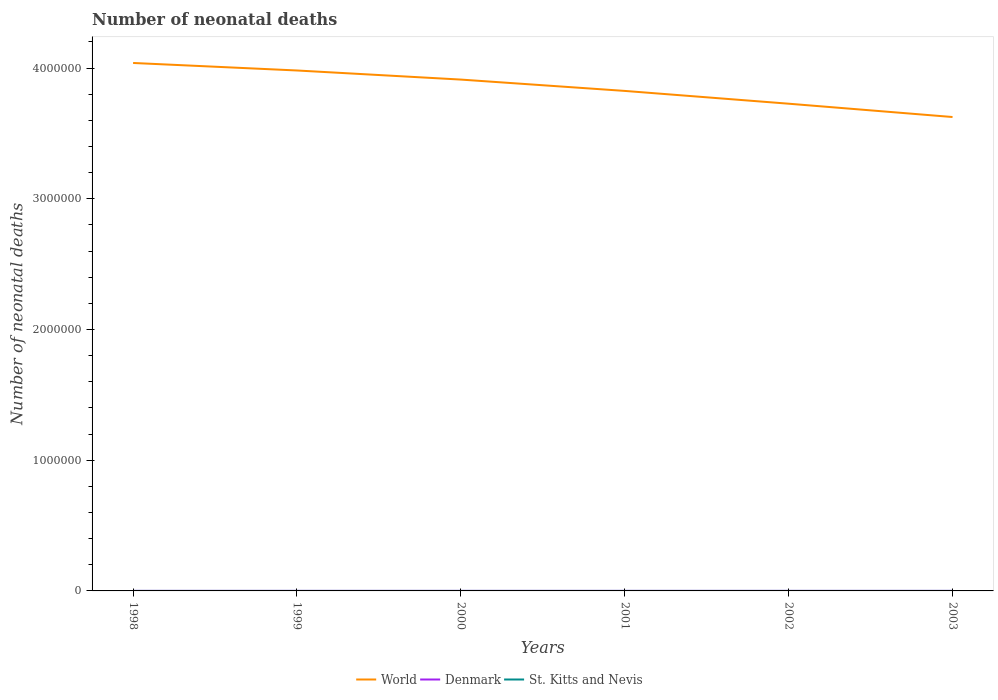Does the line corresponding to World intersect with the line corresponding to Denmark?
Your response must be concise. No. Across all years, what is the maximum number of neonatal deaths in in Denmark?
Your response must be concise. 203. In which year was the number of neonatal deaths in in Denmark maximum?
Keep it short and to the point. 2003. What is the total number of neonatal deaths in in Denmark in the graph?
Your answer should be compact. 36. What is the difference between the highest and the second highest number of neonatal deaths in in St. Kitts and Nevis?
Your answer should be compact. 3. What is the difference between the highest and the lowest number of neonatal deaths in in World?
Offer a terse response. 3. How many years are there in the graph?
Provide a succinct answer. 6. What is the difference between two consecutive major ticks on the Y-axis?
Give a very brief answer. 1.00e+06. Are the values on the major ticks of Y-axis written in scientific E-notation?
Keep it short and to the point. No. Does the graph contain any zero values?
Make the answer very short. No. Does the graph contain grids?
Make the answer very short. No. Where does the legend appear in the graph?
Provide a succinct answer. Bottom center. How are the legend labels stacked?
Offer a very short reply. Horizontal. What is the title of the graph?
Offer a terse response. Number of neonatal deaths. What is the label or title of the X-axis?
Your answer should be compact. Years. What is the label or title of the Y-axis?
Make the answer very short. Number of neonatal deaths. What is the Number of neonatal deaths in World in 1998?
Keep it short and to the point. 4.04e+06. What is the Number of neonatal deaths of Denmark in 1998?
Offer a terse response. 243. What is the Number of neonatal deaths of World in 1999?
Offer a terse response. 3.98e+06. What is the Number of neonatal deaths in Denmark in 1999?
Keep it short and to the point. 231. What is the Number of neonatal deaths in St. Kitts and Nevis in 1999?
Keep it short and to the point. 12. What is the Number of neonatal deaths of World in 2000?
Ensure brevity in your answer.  3.91e+06. What is the Number of neonatal deaths in Denmark in 2000?
Give a very brief answer. 221. What is the Number of neonatal deaths in World in 2001?
Provide a succinct answer. 3.83e+06. What is the Number of neonatal deaths in Denmark in 2001?
Give a very brief answer. 213. What is the Number of neonatal deaths of World in 2002?
Make the answer very short. 3.73e+06. What is the Number of neonatal deaths in Denmark in 2002?
Make the answer very short. 207. What is the Number of neonatal deaths in World in 2003?
Give a very brief answer. 3.63e+06. What is the Number of neonatal deaths in Denmark in 2003?
Offer a terse response. 203. Across all years, what is the maximum Number of neonatal deaths in World?
Make the answer very short. 4.04e+06. Across all years, what is the maximum Number of neonatal deaths of Denmark?
Keep it short and to the point. 243. Across all years, what is the maximum Number of neonatal deaths of St. Kitts and Nevis?
Offer a terse response. 13. Across all years, what is the minimum Number of neonatal deaths in World?
Keep it short and to the point. 3.63e+06. Across all years, what is the minimum Number of neonatal deaths of Denmark?
Your response must be concise. 203. Across all years, what is the minimum Number of neonatal deaths in St. Kitts and Nevis?
Ensure brevity in your answer.  10. What is the total Number of neonatal deaths in World in the graph?
Make the answer very short. 2.31e+07. What is the total Number of neonatal deaths in Denmark in the graph?
Provide a succinct answer. 1318. What is the difference between the Number of neonatal deaths in World in 1998 and that in 1999?
Your answer should be very brief. 5.75e+04. What is the difference between the Number of neonatal deaths of St. Kitts and Nevis in 1998 and that in 1999?
Keep it short and to the point. 1. What is the difference between the Number of neonatal deaths of World in 1998 and that in 2000?
Your response must be concise. 1.27e+05. What is the difference between the Number of neonatal deaths of Denmark in 1998 and that in 2000?
Give a very brief answer. 22. What is the difference between the Number of neonatal deaths in St. Kitts and Nevis in 1998 and that in 2000?
Your response must be concise. 1. What is the difference between the Number of neonatal deaths in World in 1998 and that in 2001?
Provide a short and direct response. 2.14e+05. What is the difference between the Number of neonatal deaths in World in 1998 and that in 2002?
Your answer should be very brief. 3.12e+05. What is the difference between the Number of neonatal deaths of World in 1998 and that in 2003?
Your answer should be compact. 4.14e+05. What is the difference between the Number of neonatal deaths of Denmark in 1998 and that in 2003?
Your answer should be compact. 40. What is the difference between the Number of neonatal deaths of World in 1999 and that in 2000?
Your answer should be very brief. 6.96e+04. What is the difference between the Number of neonatal deaths in St. Kitts and Nevis in 1999 and that in 2000?
Your answer should be very brief. 0. What is the difference between the Number of neonatal deaths in World in 1999 and that in 2001?
Make the answer very short. 1.56e+05. What is the difference between the Number of neonatal deaths of Denmark in 1999 and that in 2001?
Provide a succinct answer. 18. What is the difference between the Number of neonatal deaths of St. Kitts and Nevis in 1999 and that in 2001?
Provide a short and direct response. 1. What is the difference between the Number of neonatal deaths of World in 1999 and that in 2002?
Your answer should be compact. 2.54e+05. What is the difference between the Number of neonatal deaths of Denmark in 1999 and that in 2002?
Your answer should be very brief. 24. What is the difference between the Number of neonatal deaths in World in 1999 and that in 2003?
Keep it short and to the point. 3.56e+05. What is the difference between the Number of neonatal deaths of Denmark in 1999 and that in 2003?
Give a very brief answer. 28. What is the difference between the Number of neonatal deaths of World in 2000 and that in 2001?
Keep it short and to the point. 8.67e+04. What is the difference between the Number of neonatal deaths of St. Kitts and Nevis in 2000 and that in 2001?
Keep it short and to the point. 1. What is the difference between the Number of neonatal deaths in World in 2000 and that in 2002?
Keep it short and to the point. 1.85e+05. What is the difference between the Number of neonatal deaths of St. Kitts and Nevis in 2000 and that in 2002?
Provide a short and direct response. 2. What is the difference between the Number of neonatal deaths of World in 2000 and that in 2003?
Give a very brief answer. 2.86e+05. What is the difference between the Number of neonatal deaths in St. Kitts and Nevis in 2000 and that in 2003?
Your answer should be compact. 2. What is the difference between the Number of neonatal deaths of World in 2001 and that in 2002?
Your answer should be compact. 9.79e+04. What is the difference between the Number of neonatal deaths in St. Kitts and Nevis in 2001 and that in 2002?
Ensure brevity in your answer.  1. What is the difference between the Number of neonatal deaths in World in 2001 and that in 2003?
Your response must be concise. 2.00e+05. What is the difference between the Number of neonatal deaths of St. Kitts and Nevis in 2001 and that in 2003?
Offer a terse response. 1. What is the difference between the Number of neonatal deaths of World in 2002 and that in 2003?
Provide a succinct answer. 1.02e+05. What is the difference between the Number of neonatal deaths of Denmark in 2002 and that in 2003?
Provide a succinct answer. 4. What is the difference between the Number of neonatal deaths in World in 1998 and the Number of neonatal deaths in Denmark in 1999?
Make the answer very short. 4.04e+06. What is the difference between the Number of neonatal deaths of World in 1998 and the Number of neonatal deaths of St. Kitts and Nevis in 1999?
Keep it short and to the point. 4.04e+06. What is the difference between the Number of neonatal deaths in Denmark in 1998 and the Number of neonatal deaths in St. Kitts and Nevis in 1999?
Offer a very short reply. 231. What is the difference between the Number of neonatal deaths in World in 1998 and the Number of neonatal deaths in Denmark in 2000?
Provide a short and direct response. 4.04e+06. What is the difference between the Number of neonatal deaths of World in 1998 and the Number of neonatal deaths of St. Kitts and Nevis in 2000?
Offer a very short reply. 4.04e+06. What is the difference between the Number of neonatal deaths of Denmark in 1998 and the Number of neonatal deaths of St. Kitts and Nevis in 2000?
Offer a very short reply. 231. What is the difference between the Number of neonatal deaths of World in 1998 and the Number of neonatal deaths of Denmark in 2001?
Your answer should be compact. 4.04e+06. What is the difference between the Number of neonatal deaths in World in 1998 and the Number of neonatal deaths in St. Kitts and Nevis in 2001?
Your answer should be very brief. 4.04e+06. What is the difference between the Number of neonatal deaths of Denmark in 1998 and the Number of neonatal deaths of St. Kitts and Nevis in 2001?
Your response must be concise. 232. What is the difference between the Number of neonatal deaths in World in 1998 and the Number of neonatal deaths in Denmark in 2002?
Your answer should be very brief. 4.04e+06. What is the difference between the Number of neonatal deaths in World in 1998 and the Number of neonatal deaths in St. Kitts and Nevis in 2002?
Offer a terse response. 4.04e+06. What is the difference between the Number of neonatal deaths in Denmark in 1998 and the Number of neonatal deaths in St. Kitts and Nevis in 2002?
Offer a terse response. 233. What is the difference between the Number of neonatal deaths in World in 1998 and the Number of neonatal deaths in Denmark in 2003?
Provide a short and direct response. 4.04e+06. What is the difference between the Number of neonatal deaths in World in 1998 and the Number of neonatal deaths in St. Kitts and Nevis in 2003?
Your answer should be very brief. 4.04e+06. What is the difference between the Number of neonatal deaths in Denmark in 1998 and the Number of neonatal deaths in St. Kitts and Nevis in 2003?
Your answer should be compact. 233. What is the difference between the Number of neonatal deaths of World in 1999 and the Number of neonatal deaths of Denmark in 2000?
Provide a succinct answer. 3.98e+06. What is the difference between the Number of neonatal deaths in World in 1999 and the Number of neonatal deaths in St. Kitts and Nevis in 2000?
Offer a very short reply. 3.98e+06. What is the difference between the Number of neonatal deaths in Denmark in 1999 and the Number of neonatal deaths in St. Kitts and Nevis in 2000?
Provide a succinct answer. 219. What is the difference between the Number of neonatal deaths in World in 1999 and the Number of neonatal deaths in Denmark in 2001?
Your answer should be very brief. 3.98e+06. What is the difference between the Number of neonatal deaths of World in 1999 and the Number of neonatal deaths of St. Kitts and Nevis in 2001?
Offer a terse response. 3.98e+06. What is the difference between the Number of neonatal deaths in Denmark in 1999 and the Number of neonatal deaths in St. Kitts and Nevis in 2001?
Provide a succinct answer. 220. What is the difference between the Number of neonatal deaths in World in 1999 and the Number of neonatal deaths in Denmark in 2002?
Give a very brief answer. 3.98e+06. What is the difference between the Number of neonatal deaths of World in 1999 and the Number of neonatal deaths of St. Kitts and Nevis in 2002?
Ensure brevity in your answer.  3.98e+06. What is the difference between the Number of neonatal deaths in Denmark in 1999 and the Number of neonatal deaths in St. Kitts and Nevis in 2002?
Keep it short and to the point. 221. What is the difference between the Number of neonatal deaths of World in 1999 and the Number of neonatal deaths of Denmark in 2003?
Ensure brevity in your answer.  3.98e+06. What is the difference between the Number of neonatal deaths of World in 1999 and the Number of neonatal deaths of St. Kitts and Nevis in 2003?
Make the answer very short. 3.98e+06. What is the difference between the Number of neonatal deaths in Denmark in 1999 and the Number of neonatal deaths in St. Kitts and Nevis in 2003?
Make the answer very short. 221. What is the difference between the Number of neonatal deaths of World in 2000 and the Number of neonatal deaths of Denmark in 2001?
Offer a terse response. 3.91e+06. What is the difference between the Number of neonatal deaths in World in 2000 and the Number of neonatal deaths in St. Kitts and Nevis in 2001?
Ensure brevity in your answer.  3.91e+06. What is the difference between the Number of neonatal deaths in Denmark in 2000 and the Number of neonatal deaths in St. Kitts and Nevis in 2001?
Your response must be concise. 210. What is the difference between the Number of neonatal deaths of World in 2000 and the Number of neonatal deaths of Denmark in 2002?
Give a very brief answer. 3.91e+06. What is the difference between the Number of neonatal deaths of World in 2000 and the Number of neonatal deaths of St. Kitts and Nevis in 2002?
Provide a short and direct response. 3.91e+06. What is the difference between the Number of neonatal deaths of Denmark in 2000 and the Number of neonatal deaths of St. Kitts and Nevis in 2002?
Your response must be concise. 211. What is the difference between the Number of neonatal deaths of World in 2000 and the Number of neonatal deaths of Denmark in 2003?
Make the answer very short. 3.91e+06. What is the difference between the Number of neonatal deaths in World in 2000 and the Number of neonatal deaths in St. Kitts and Nevis in 2003?
Provide a succinct answer. 3.91e+06. What is the difference between the Number of neonatal deaths in Denmark in 2000 and the Number of neonatal deaths in St. Kitts and Nevis in 2003?
Your response must be concise. 211. What is the difference between the Number of neonatal deaths of World in 2001 and the Number of neonatal deaths of Denmark in 2002?
Offer a terse response. 3.83e+06. What is the difference between the Number of neonatal deaths of World in 2001 and the Number of neonatal deaths of St. Kitts and Nevis in 2002?
Offer a very short reply. 3.83e+06. What is the difference between the Number of neonatal deaths in Denmark in 2001 and the Number of neonatal deaths in St. Kitts and Nevis in 2002?
Provide a short and direct response. 203. What is the difference between the Number of neonatal deaths of World in 2001 and the Number of neonatal deaths of Denmark in 2003?
Offer a very short reply. 3.83e+06. What is the difference between the Number of neonatal deaths in World in 2001 and the Number of neonatal deaths in St. Kitts and Nevis in 2003?
Your answer should be very brief. 3.83e+06. What is the difference between the Number of neonatal deaths of Denmark in 2001 and the Number of neonatal deaths of St. Kitts and Nevis in 2003?
Your answer should be very brief. 203. What is the difference between the Number of neonatal deaths of World in 2002 and the Number of neonatal deaths of Denmark in 2003?
Ensure brevity in your answer.  3.73e+06. What is the difference between the Number of neonatal deaths of World in 2002 and the Number of neonatal deaths of St. Kitts and Nevis in 2003?
Give a very brief answer. 3.73e+06. What is the difference between the Number of neonatal deaths of Denmark in 2002 and the Number of neonatal deaths of St. Kitts and Nevis in 2003?
Your answer should be compact. 197. What is the average Number of neonatal deaths of World per year?
Your answer should be compact. 3.85e+06. What is the average Number of neonatal deaths in Denmark per year?
Make the answer very short. 219.67. What is the average Number of neonatal deaths of St. Kitts and Nevis per year?
Your answer should be very brief. 11.33. In the year 1998, what is the difference between the Number of neonatal deaths in World and Number of neonatal deaths in Denmark?
Give a very brief answer. 4.04e+06. In the year 1998, what is the difference between the Number of neonatal deaths of World and Number of neonatal deaths of St. Kitts and Nevis?
Your response must be concise. 4.04e+06. In the year 1998, what is the difference between the Number of neonatal deaths in Denmark and Number of neonatal deaths in St. Kitts and Nevis?
Your answer should be compact. 230. In the year 1999, what is the difference between the Number of neonatal deaths of World and Number of neonatal deaths of Denmark?
Give a very brief answer. 3.98e+06. In the year 1999, what is the difference between the Number of neonatal deaths of World and Number of neonatal deaths of St. Kitts and Nevis?
Give a very brief answer. 3.98e+06. In the year 1999, what is the difference between the Number of neonatal deaths in Denmark and Number of neonatal deaths in St. Kitts and Nevis?
Ensure brevity in your answer.  219. In the year 2000, what is the difference between the Number of neonatal deaths in World and Number of neonatal deaths in Denmark?
Keep it short and to the point. 3.91e+06. In the year 2000, what is the difference between the Number of neonatal deaths of World and Number of neonatal deaths of St. Kitts and Nevis?
Make the answer very short. 3.91e+06. In the year 2000, what is the difference between the Number of neonatal deaths of Denmark and Number of neonatal deaths of St. Kitts and Nevis?
Ensure brevity in your answer.  209. In the year 2001, what is the difference between the Number of neonatal deaths of World and Number of neonatal deaths of Denmark?
Your response must be concise. 3.83e+06. In the year 2001, what is the difference between the Number of neonatal deaths in World and Number of neonatal deaths in St. Kitts and Nevis?
Provide a short and direct response. 3.83e+06. In the year 2001, what is the difference between the Number of neonatal deaths in Denmark and Number of neonatal deaths in St. Kitts and Nevis?
Offer a terse response. 202. In the year 2002, what is the difference between the Number of neonatal deaths of World and Number of neonatal deaths of Denmark?
Make the answer very short. 3.73e+06. In the year 2002, what is the difference between the Number of neonatal deaths of World and Number of neonatal deaths of St. Kitts and Nevis?
Ensure brevity in your answer.  3.73e+06. In the year 2002, what is the difference between the Number of neonatal deaths of Denmark and Number of neonatal deaths of St. Kitts and Nevis?
Keep it short and to the point. 197. In the year 2003, what is the difference between the Number of neonatal deaths in World and Number of neonatal deaths in Denmark?
Offer a terse response. 3.63e+06. In the year 2003, what is the difference between the Number of neonatal deaths of World and Number of neonatal deaths of St. Kitts and Nevis?
Your answer should be compact. 3.63e+06. In the year 2003, what is the difference between the Number of neonatal deaths in Denmark and Number of neonatal deaths in St. Kitts and Nevis?
Your answer should be compact. 193. What is the ratio of the Number of neonatal deaths of World in 1998 to that in 1999?
Ensure brevity in your answer.  1.01. What is the ratio of the Number of neonatal deaths of Denmark in 1998 to that in 1999?
Your response must be concise. 1.05. What is the ratio of the Number of neonatal deaths in St. Kitts and Nevis in 1998 to that in 1999?
Ensure brevity in your answer.  1.08. What is the ratio of the Number of neonatal deaths in World in 1998 to that in 2000?
Ensure brevity in your answer.  1.03. What is the ratio of the Number of neonatal deaths of Denmark in 1998 to that in 2000?
Your answer should be very brief. 1.1. What is the ratio of the Number of neonatal deaths in World in 1998 to that in 2001?
Offer a terse response. 1.06. What is the ratio of the Number of neonatal deaths of Denmark in 1998 to that in 2001?
Keep it short and to the point. 1.14. What is the ratio of the Number of neonatal deaths of St. Kitts and Nevis in 1998 to that in 2001?
Make the answer very short. 1.18. What is the ratio of the Number of neonatal deaths in World in 1998 to that in 2002?
Keep it short and to the point. 1.08. What is the ratio of the Number of neonatal deaths in Denmark in 1998 to that in 2002?
Offer a terse response. 1.17. What is the ratio of the Number of neonatal deaths of World in 1998 to that in 2003?
Your response must be concise. 1.11. What is the ratio of the Number of neonatal deaths of Denmark in 1998 to that in 2003?
Ensure brevity in your answer.  1.2. What is the ratio of the Number of neonatal deaths of World in 1999 to that in 2000?
Give a very brief answer. 1.02. What is the ratio of the Number of neonatal deaths of Denmark in 1999 to that in 2000?
Keep it short and to the point. 1.05. What is the ratio of the Number of neonatal deaths in St. Kitts and Nevis in 1999 to that in 2000?
Your answer should be compact. 1. What is the ratio of the Number of neonatal deaths of World in 1999 to that in 2001?
Your response must be concise. 1.04. What is the ratio of the Number of neonatal deaths in Denmark in 1999 to that in 2001?
Give a very brief answer. 1.08. What is the ratio of the Number of neonatal deaths in St. Kitts and Nevis in 1999 to that in 2001?
Your answer should be very brief. 1.09. What is the ratio of the Number of neonatal deaths of World in 1999 to that in 2002?
Offer a terse response. 1.07. What is the ratio of the Number of neonatal deaths in Denmark in 1999 to that in 2002?
Offer a terse response. 1.12. What is the ratio of the Number of neonatal deaths of World in 1999 to that in 2003?
Ensure brevity in your answer.  1.1. What is the ratio of the Number of neonatal deaths in Denmark in 1999 to that in 2003?
Your answer should be very brief. 1.14. What is the ratio of the Number of neonatal deaths of World in 2000 to that in 2001?
Give a very brief answer. 1.02. What is the ratio of the Number of neonatal deaths of Denmark in 2000 to that in 2001?
Ensure brevity in your answer.  1.04. What is the ratio of the Number of neonatal deaths in St. Kitts and Nevis in 2000 to that in 2001?
Keep it short and to the point. 1.09. What is the ratio of the Number of neonatal deaths of World in 2000 to that in 2002?
Your response must be concise. 1.05. What is the ratio of the Number of neonatal deaths in Denmark in 2000 to that in 2002?
Provide a short and direct response. 1.07. What is the ratio of the Number of neonatal deaths in St. Kitts and Nevis in 2000 to that in 2002?
Offer a terse response. 1.2. What is the ratio of the Number of neonatal deaths in World in 2000 to that in 2003?
Make the answer very short. 1.08. What is the ratio of the Number of neonatal deaths in Denmark in 2000 to that in 2003?
Ensure brevity in your answer.  1.09. What is the ratio of the Number of neonatal deaths in St. Kitts and Nevis in 2000 to that in 2003?
Provide a short and direct response. 1.2. What is the ratio of the Number of neonatal deaths in World in 2001 to that in 2002?
Your answer should be very brief. 1.03. What is the ratio of the Number of neonatal deaths in Denmark in 2001 to that in 2002?
Provide a short and direct response. 1.03. What is the ratio of the Number of neonatal deaths of World in 2001 to that in 2003?
Your response must be concise. 1.06. What is the ratio of the Number of neonatal deaths of Denmark in 2001 to that in 2003?
Offer a very short reply. 1.05. What is the ratio of the Number of neonatal deaths in St. Kitts and Nevis in 2001 to that in 2003?
Make the answer very short. 1.1. What is the ratio of the Number of neonatal deaths in World in 2002 to that in 2003?
Make the answer very short. 1.03. What is the ratio of the Number of neonatal deaths of Denmark in 2002 to that in 2003?
Give a very brief answer. 1.02. What is the ratio of the Number of neonatal deaths of St. Kitts and Nevis in 2002 to that in 2003?
Provide a succinct answer. 1. What is the difference between the highest and the second highest Number of neonatal deaths in World?
Your answer should be compact. 5.75e+04. What is the difference between the highest and the second highest Number of neonatal deaths in Denmark?
Offer a very short reply. 12. What is the difference between the highest and the lowest Number of neonatal deaths of World?
Your answer should be very brief. 4.14e+05. 